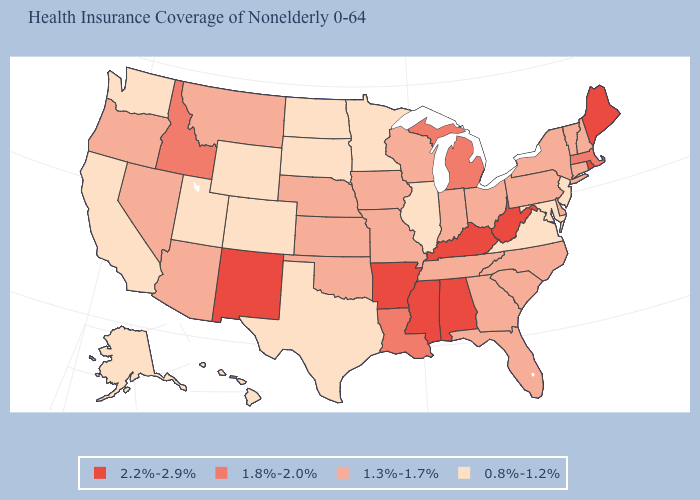What is the lowest value in states that border Tennessee?
Keep it brief. 0.8%-1.2%. What is the value of Vermont?
Concise answer only. 1.3%-1.7%. How many symbols are there in the legend?
Be succinct. 4. Name the states that have a value in the range 0.8%-1.2%?
Give a very brief answer. Alaska, California, Colorado, Hawaii, Illinois, Maryland, Minnesota, New Jersey, North Dakota, South Dakota, Texas, Utah, Virginia, Washington, Wyoming. What is the value of South Carolina?
Concise answer only. 1.3%-1.7%. What is the value of Massachusetts?
Give a very brief answer. 1.8%-2.0%. Which states have the highest value in the USA?
Be succinct. Alabama, Arkansas, Kentucky, Maine, Mississippi, New Mexico, Rhode Island, West Virginia. Does North Carolina have a higher value than Indiana?
Short answer required. No. Name the states that have a value in the range 1.3%-1.7%?
Quick response, please. Arizona, Connecticut, Delaware, Florida, Georgia, Indiana, Iowa, Kansas, Missouri, Montana, Nebraska, Nevada, New Hampshire, New York, North Carolina, Ohio, Oklahoma, Oregon, Pennsylvania, South Carolina, Tennessee, Vermont, Wisconsin. Name the states that have a value in the range 1.8%-2.0%?
Write a very short answer. Idaho, Louisiana, Massachusetts, Michigan. Name the states that have a value in the range 1.8%-2.0%?
Give a very brief answer. Idaho, Louisiana, Massachusetts, Michigan. Name the states that have a value in the range 1.8%-2.0%?
Concise answer only. Idaho, Louisiana, Massachusetts, Michigan. Which states hav the highest value in the West?
Concise answer only. New Mexico. Name the states that have a value in the range 2.2%-2.9%?
Write a very short answer. Alabama, Arkansas, Kentucky, Maine, Mississippi, New Mexico, Rhode Island, West Virginia. What is the value of New York?
Quick response, please. 1.3%-1.7%. 